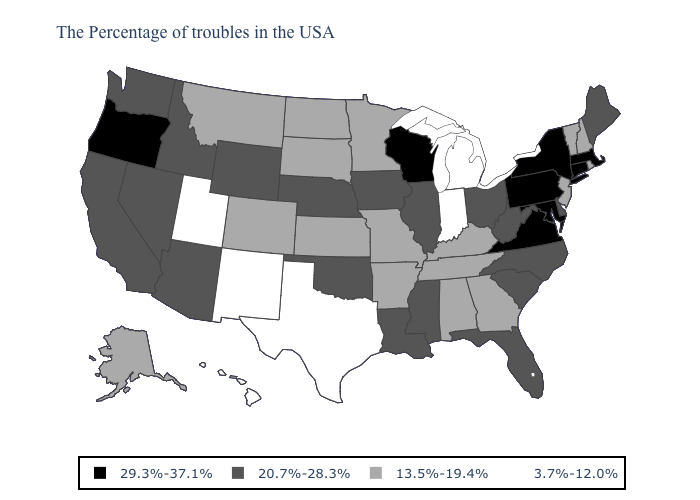Among the states that border New Jersey , which have the lowest value?
Short answer required. Delaware. Which states have the lowest value in the Northeast?
Keep it brief. Rhode Island, New Hampshire, Vermont, New Jersey. Does the map have missing data?
Concise answer only. No. Which states hav the highest value in the Northeast?
Write a very short answer. Massachusetts, Connecticut, New York, Pennsylvania. Name the states that have a value in the range 29.3%-37.1%?
Concise answer only. Massachusetts, Connecticut, New York, Maryland, Pennsylvania, Virginia, Wisconsin, Oregon. Does New Jersey have the same value as Mississippi?
Concise answer only. No. Name the states that have a value in the range 3.7%-12.0%?
Concise answer only. Michigan, Indiana, Texas, New Mexico, Utah, Hawaii. Name the states that have a value in the range 13.5%-19.4%?
Short answer required. Rhode Island, New Hampshire, Vermont, New Jersey, Georgia, Kentucky, Alabama, Tennessee, Missouri, Arkansas, Minnesota, Kansas, South Dakota, North Dakota, Colorado, Montana, Alaska. What is the value of Wisconsin?
Keep it brief. 29.3%-37.1%. Does Wisconsin have the highest value in the MidWest?
Give a very brief answer. Yes. Name the states that have a value in the range 3.7%-12.0%?
Write a very short answer. Michigan, Indiana, Texas, New Mexico, Utah, Hawaii. Does Massachusetts have the highest value in the USA?
Be succinct. Yes. What is the value of Arizona?
Give a very brief answer. 20.7%-28.3%. Which states have the highest value in the USA?
Keep it brief. Massachusetts, Connecticut, New York, Maryland, Pennsylvania, Virginia, Wisconsin, Oregon. Does Tennessee have a higher value than Hawaii?
Quick response, please. Yes. 